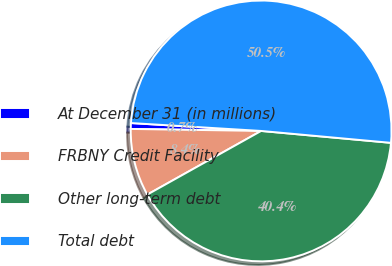Convert chart. <chart><loc_0><loc_0><loc_500><loc_500><pie_chart><fcel>At December 31 (in millions)<fcel>FRBNY Credit Facility<fcel>Other long-term debt<fcel>Total debt<nl><fcel>0.72%<fcel>8.36%<fcel>40.43%<fcel>50.49%<nl></chart> 